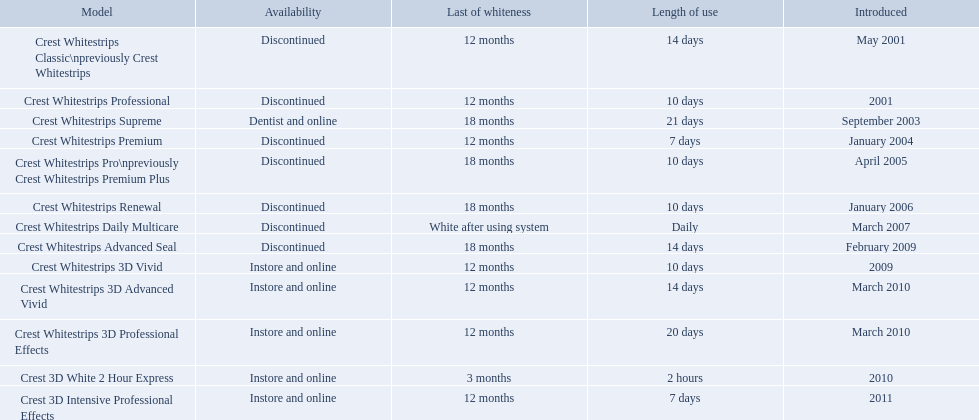What are all the models? Crest Whitestrips Classic\npreviously Crest Whitestrips, Crest Whitestrips Professional, Crest Whitestrips Supreme, Crest Whitestrips Premium, Crest Whitestrips Pro\npreviously Crest Whitestrips Premium Plus, Crest Whitestrips Renewal, Crest Whitestrips Daily Multicare, Crest Whitestrips Advanced Seal, Crest Whitestrips 3D Vivid, Crest Whitestrips 3D Advanced Vivid, Crest Whitestrips 3D Professional Effects, Crest 3D White 2 Hour Express, Crest 3D Intensive Professional Effects. Of these, for which can a ratio be calculated for 'length of use' to 'last of whiteness'? Crest Whitestrips Classic\npreviously Crest Whitestrips, Crest Whitestrips Professional, Crest Whitestrips Supreme, Crest Whitestrips Premium, Crest Whitestrips Pro\npreviously Crest Whitestrips Premium Plus, Crest Whitestrips Renewal, Crest Whitestrips Advanced Seal, Crest Whitestrips 3D Vivid, Crest Whitestrips 3D Advanced Vivid, Crest Whitestrips 3D Professional Effects, Crest 3D White 2 Hour Express, Crest 3D Intensive Professional Effects. Which has the highest ratio? Crest Whitestrips Supreme. What year did crest come out with crest white strips 3d vivid? 2009. Which crest product was also introduced he same year, but is now discontinued? Crest Whitestrips Advanced Seal. Which of these products are discontinued? Crest Whitestrips Classic\npreviously Crest Whitestrips, Crest Whitestrips Professional, Crest Whitestrips Premium, Crest Whitestrips Pro\npreviously Crest Whitestrips Premium Plus, Crest Whitestrips Renewal, Crest Whitestrips Daily Multicare, Crest Whitestrips Advanced Seal. Which of these products have a 14 day length of use? Crest Whitestrips Classic\npreviously Crest Whitestrips, Crest Whitestrips Advanced Seal. Which of these products was introduced in 2009? Crest Whitestrips Advanced Seal. 